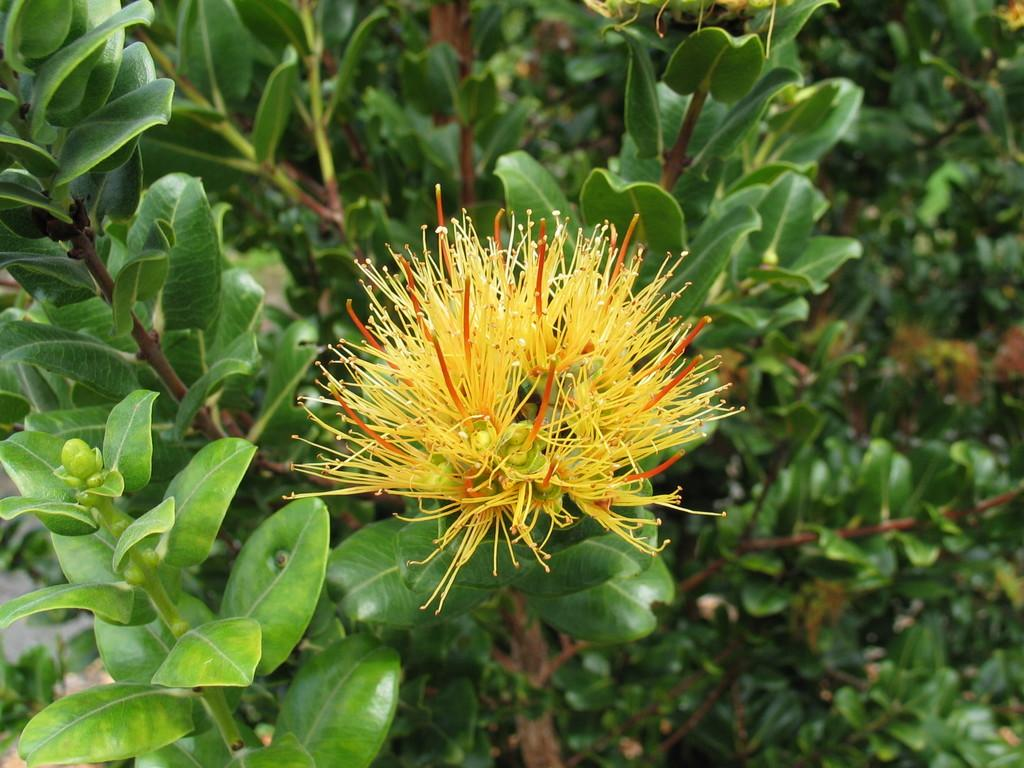What is the main subject of the image? There is a flower in the image. What color is the flower? The flower is yellow. What else can be seen in the image besides the flower? There are green leaves in the image. Are there any other plants visible in the image? Yes, there are plants on either side of the flower. What type of curve can be seen in the image? There is no curve present in the image; it features a flower, green leaves, and plants on either side. Can you tell me how many skateboards are visible in the image? There are no skateboards present in the image. 